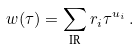Convert formula to latex. <formula><loc_0><loc_0><loc_500><loc_500>w ( \tau ) = \sum _ { \text {IR} } r _ { i } \tau ^ { u _ { i } } \, .</formula> 